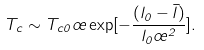<formula> <loc_0><loc_0><loc_500><loc_500>T _ { c } \sim T _ { c 0 } \sigma \exp [ - \frac { ( l _ { 0 } - \bar { l } ) } { l _ { 0 } \sigma ^ { 2 } } ] .</formula> 